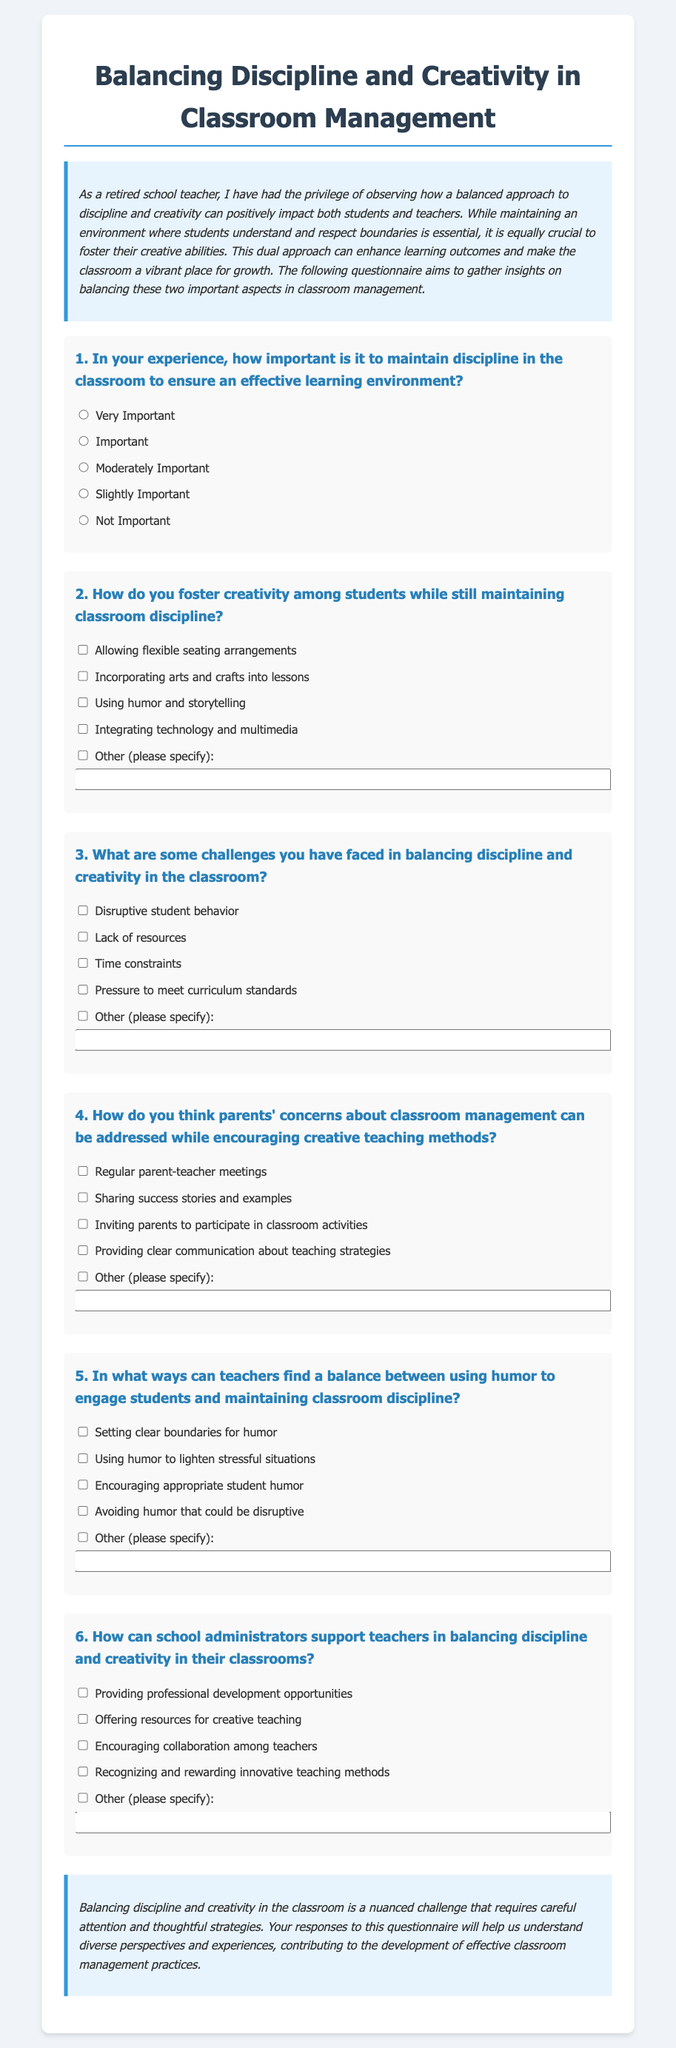What is the title of the document? The title of the document is stated in the header section of the HTML.
Answer: Balancing Discipline and Creativity in Classroom Management How many questions are there in the questionnaire? The document contains a total of six questions listed under the questionnaire.
Answer: 6 What is the purpose of the questionnaire? The purpose is detailed in the introductory paragraph, explicitly mentioning the aim of gathering insights.
Answer: To gather insights on balancing discipline and creativity In question 5, what does the option "Setting clear boundaries for humor" pertain to? This option refers to strategies teachers can use in balancing humor and discipline in the classroom context as outlined in question 5.
Answer: Balance between humor and discipline Which option suggests involving parents in classroom activities? The relevant option appears under question 4 and suggests a way to engage parents in the management process.
Answer: Inviting parents to participate in classroom activities What color is used for the background of the conclusion section? The background color of the conclusion section is mentioned in the style rules of the document.
Answer: Light blue 